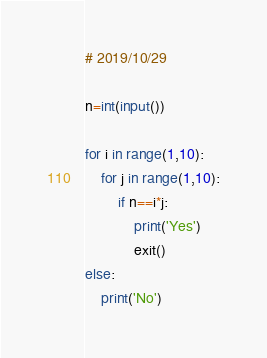<code> <loc_0><loc_0><loc_500><loc_500><_Python_># 2019/10/29

n=int(input())

for i in range(1,10):
    for j in range(1,10):
        if n==i*j:
            print('Yes')
            exit()
else:
    print('No')</code> 